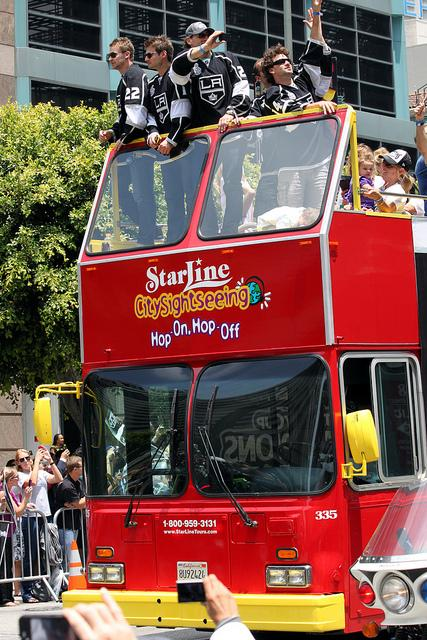The person on the motorcycle escorting the double decker bus is what type of public servant? police 